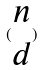<formula> <loc_0><loc_0><loc_500><loc_500>( \begin{matrix} n \\ d \end{matrix} )</formula> 